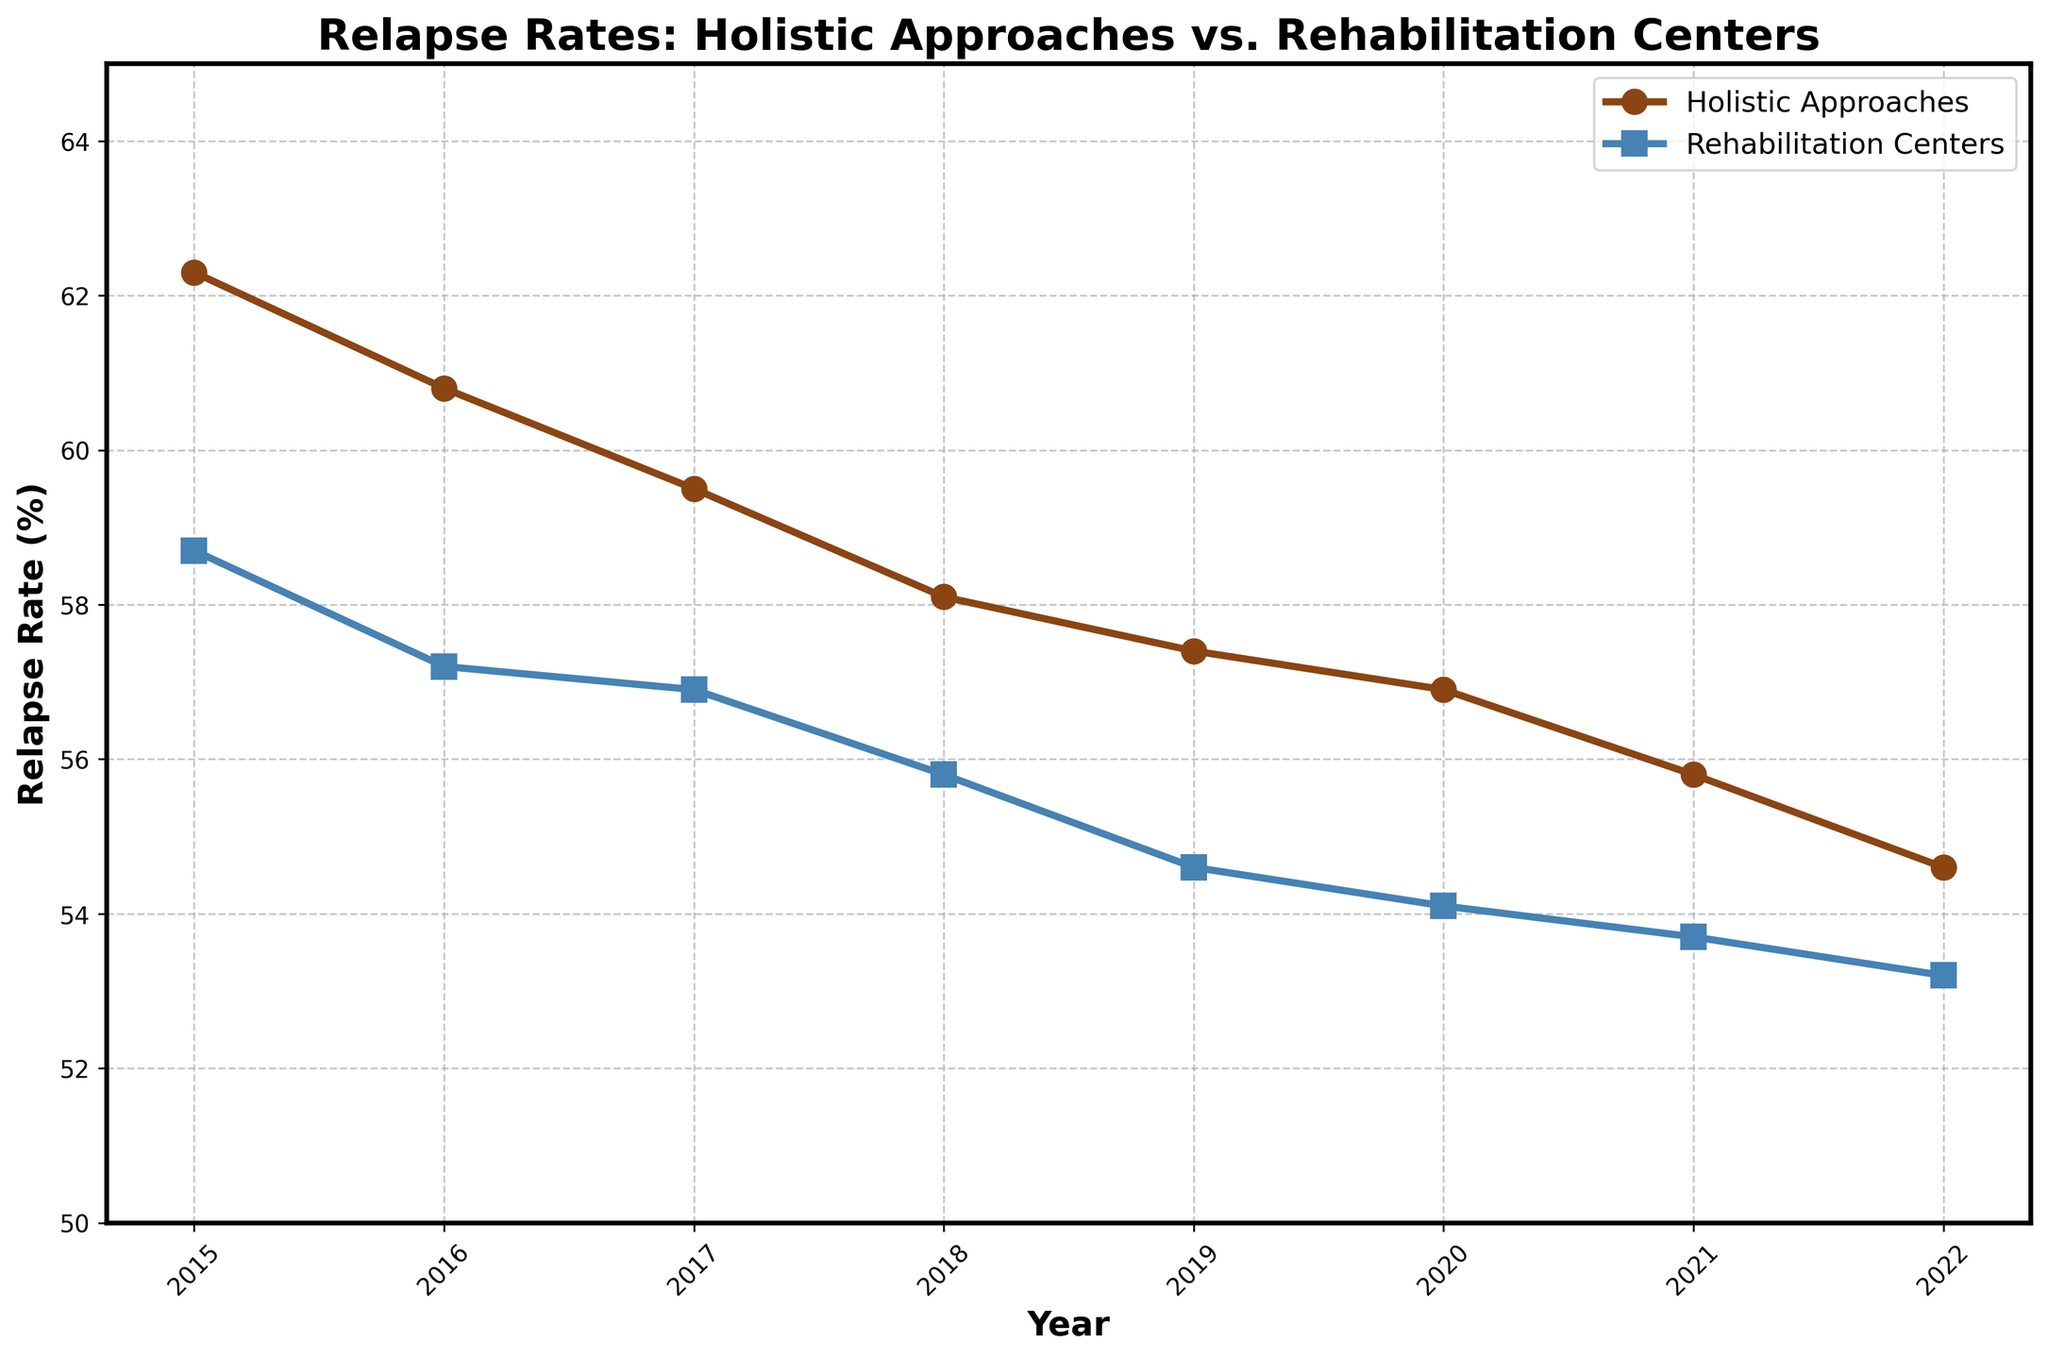What is the trend in relapse rates for individuals using holistic approaches from 2015 to 2022? The trend for the relapse rates of individuals using holistic approaches showed a consistent decline over the years from 2015, where it was 62.3%, to 2022, where it was 54.6%. This indicates an overall improvement.
Answer: Consistent decline How do the relapse rates in 2022 for holistic approaches compare to rehabilitation centers? In 2022, the relapse rate for holistic approaches was 54.6%, while for rehabilitation centers, it was 53.2%. The rate for holistic approaches was slightly higher.
Answer: Higher What is the difference in relapse rates between holistic approaches and rehabilitation centers in 2019? The relapse rate for holistic approaches in 2019 was 57.4%, while for rehabilitation centers, it was 54.6%. The difference is 57.4% - 54.6% = 2.8%.
Answer: 2.8% What is the average relapse rate for holistic approaches over the given years? The relapse rates for holistic approaches are: 62.3, 60.8, 59.5, 58.1, 57.4, 56.9, 55.8, 54.6. The average is (62.3 + 60.8 + 59.5 + 58.1 + 57.4 + 56.9 + 55.8 + 54.6) / 8 = 57.925%.
Answer: 57.93% What is the overall trend in relapse rates for rehabilitation centers from 2015 to 2022? The trend for rehabilitation centers shows a consistent decline from 58.7% in 2015 to 53.2% in 2022, indicating regular improvement over the years.
Answer: Consistent decline Calculate the mean decrease per year for holistic approaches between 2015 and 2022. The decrease from 2015 (62.3%) to 2022 (54.6%) is 62.3% - 54.6% = 7.7%. Over 7 years, the mean decrease per year is 7.7% / 7 ≈ 1.1%.
Answer: 1.1% In 2020, which group had a higher relapse rate and by how much? In 2020, holistic approaches had a relapse rate of 56.9%, while rehabilitation centers had 54.1%. The difference is 56.9% - 54.1% = 2.8%. Holistic approaches had a higher relapse rate by 2.8%.
Answer: Holistic approaches by 2.8% By how much did the relapse rate for holistic approaches decrease from 2015 to 2021? The rate in 2015 was 62.3%, and in 2021 it was 55.8%. The decrease is 62.3% - 55.8% = 6.5%.
Answer: 6.5% 